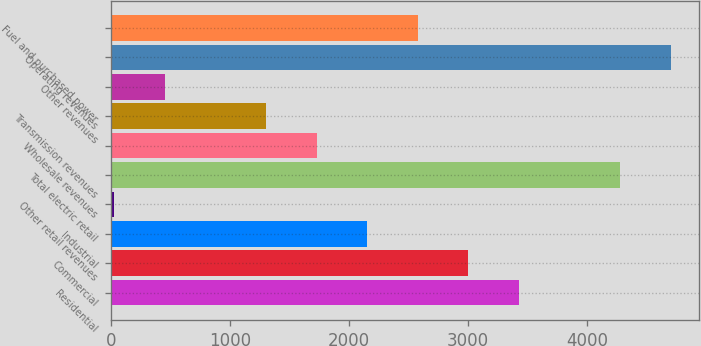Convert chart to OTSL. <chart><loc_0><loc_0><loc_500><loc_500><bar_chart><fcel>Residential<fcel>Commercial<fcel>Industrial<fcel>Other retail revenues<fcel>Total electric retail<fcel>Wholesale revenues<fcel>Transmission revenues<fcel>Other revenues<fcel>Operating revenues<fcel>Fuel and purchased power<nl><fcel>3426.84<fcel>3002.31<fcel>2153.25<fcel>30.6<fcel>4275.9<fcel>1728.72<fcel>1304.19<fcel>455.13<fcel>4700.43<fcel>2577.78<nl></chart> 